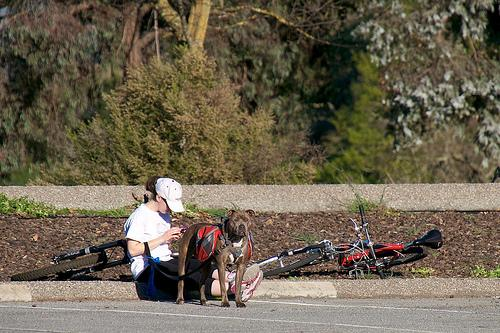Provide a brief description of the scene involving the woman and her pet. A woman wearing a white hat and shirt, along with black yoga pants, is sitting on the ground, playing with her phone while her brown dog wearing a red vest stands close by. What is the setting of this image? The setting is an outdoor concrete parking lot, surrounded by green foliage, trees, and bushes. Describe the overall atmosphere of the image. The image has a casual, relaxed atmosphere featuring a woman leisurely sitting on the curb with her dog, surrounded by nature and a few bikes in a parking lot. How is the woman interacting with her dog? The woman is holding the black leash of her brown dog wearing a red vest, while she plays with her phone. Detail the appearance of the parking lot in this image. The concrete parking lot is grey with white stripes, surrounded by greenery like a cedar tree, a leafy green tree, and a green bush in the background. What are some objects seen on the ground in this image? Objects on the ground include two bikes (one black, one red), a woman sitting on the curb, a parking lot with white lines, and a brown dog standing. Choose one of the dogs in the image and describe its appearance and accessories. The brown dog is wearing a red vest and is standing near the woman. It has brown ears and legs. Explain a detail about the woman's clothing and pose. The woman is wearing a white hat on her head and is sitting on a curb while she looks at her phone. Identify and describe the elements related to a pet in this image. The image contains a brown dog in a red vest, a blue ribbon tied to its leash, and the woman holding a black leash. In a few sentences, mention the bikes present in the image and their features. There are two bikes: a black bike lying to the left of the woman with a black wheel, and a red bike on the ground to her right, featuring a black seat and red frame. 